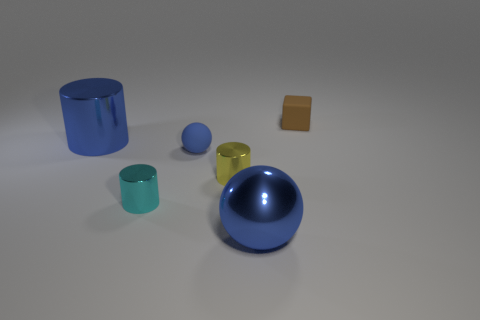Add 1 small cylinders. How many objects exist? 7 Subtract all spheres. How many objects are left? 4 Add 5 large blue metal objects. How many large blue metal objects are left? 7 Add 1 large red rubber blocks. How many large red rubber blocks exist? 1 Subtract 0 cyan cubes. How many objects are left? 6 Subtract all small blue objects. Subtract all tiny blue rubber objects. How many objects are left? 4 